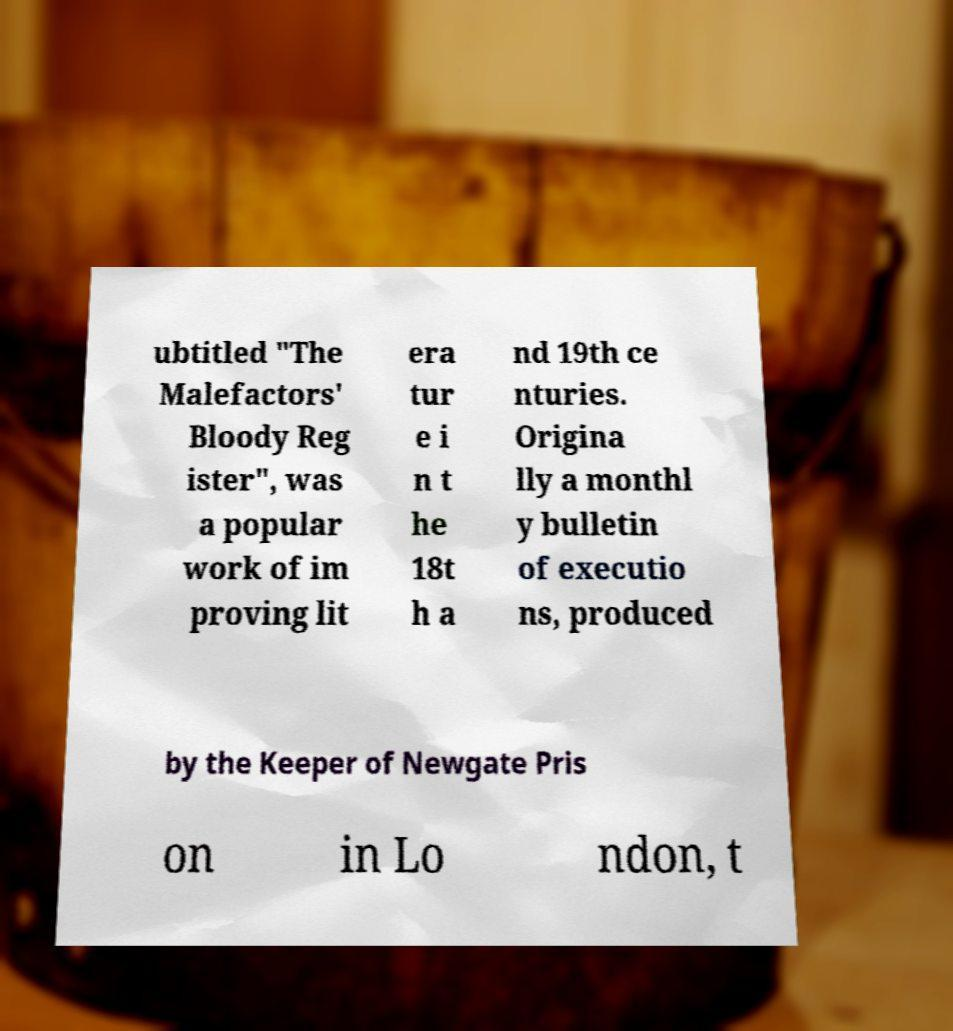For documentation purposes, I need the text within this image transcribed. Could you provide that? ubtitled "The Malefactors' Bloody Reg ister", was a popular work of im proving lit era tur e i n t he 18t h a nd 19th ce nturies. Origina lly a monthl y bulletin of executio ns, produced by the Keeper of Newgate Pris on in Lo ndon, t 